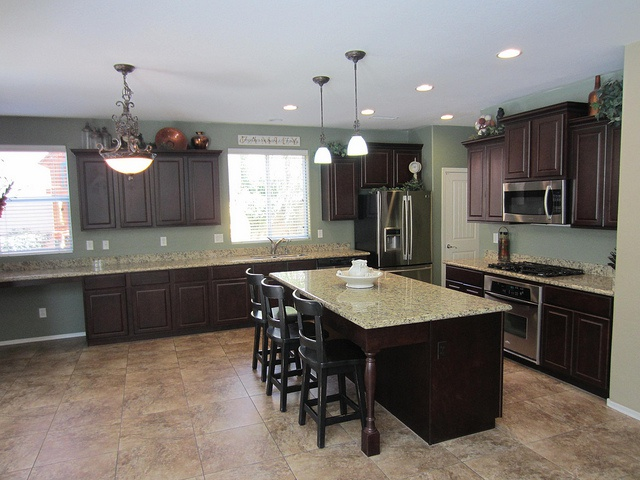Describe the objects in this image and their specific colors. I can see dining table in darkgray, tan, black, and ivory tones, chair in darkgray, black, and gray tones, refrigerator in darkgray, black, and gray tones, oven in darkgray, black, gray, and maroon tones, and chair in darkgray, black, and gray tones in this image. 